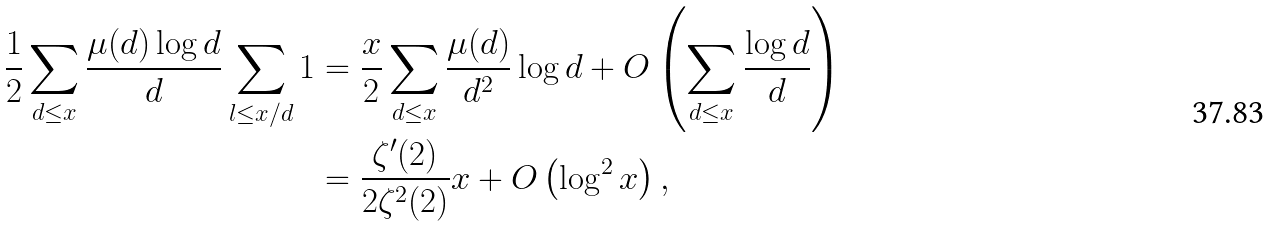<formula> <loc_0><loc_0><loc_500><loc_500>\frac { 1 } { 2 } \sum _ { d \leq x } \frac { \mu ( d ) \log d } { d } \sum _ { l \leq x / d } 1 & = \frac { x } { 2 } \sum _ { d \leq x } \frac { \mu ( d ) } { d ^ { 2 } } \log d + O \left ( \sum _ { d \leq x } \frac { \log d } { d } \right ) \\ & = \frac { \zeta ^ { \prime } ( 2 ) } { 2 \zeta ^ { 2 } ( 2 ) } x + O \left ( \log ^ { 2 } x \right ) ,</formula> 